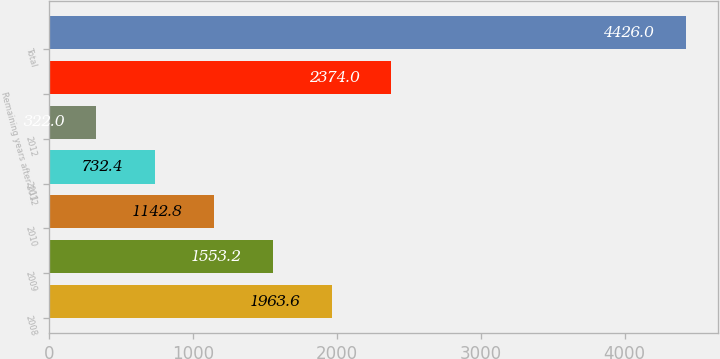Convert chart to OTSL. <chart><loc_0><loc_0><loc_500><loc_500><bar_chart><fcel>2008<fcel>2009<fcel>2010<fcel>2011<fcel>2012<fcel>Remaining years after 2012<fcel>Total<nl><fcel>1963.6<fcel>1553.2<fcel>1142.8<fcel>732.4<fcel>322<fcel>2374<fcel>4426<nl></chart> 